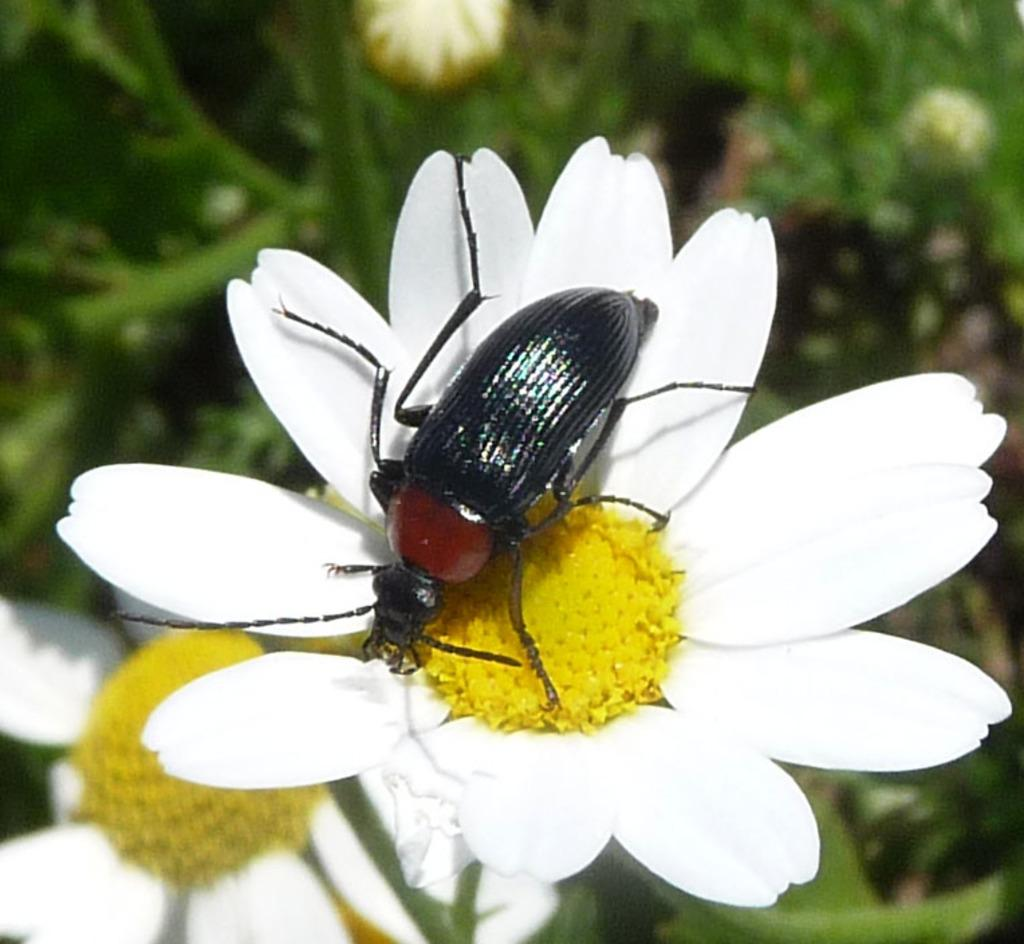What is the main subject of the image? There is an insect on a flower in the image. How is the background of the image depicted? The background of the image is blurred. Are there any other flowers visible in the image? Yes, there is another flower in the bottom left corner of the image. Where is the flock of birds flying over the lake in the image? There is no lake or flock of birds present in the image; it features an insect on a flower with a blurred background. What type of apparel is the insect wearing in the image? Insects do not wear apparel, so this question cannot be answered. 